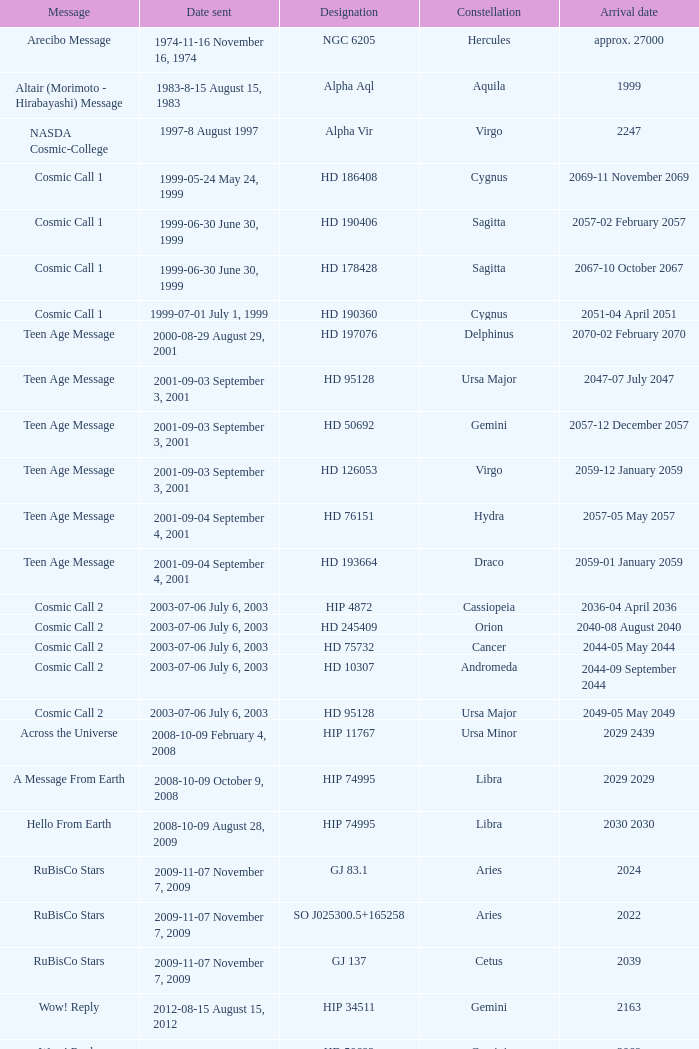Parse the table in full. {'header': ['Message', 'Date sent', 'Designation', 'Constellation', 'Arrival date'], 'rows': [['Arecibo Message', '1974-11-16 November 16, 1974', 'NGC 6205', 'Hercules', 'approx. 27000'], ['Altair (Morimoto - Hirabayashi) Message', '1983-8-15 August 15, 1983', 'Alpha Aql', 'Aquila', '1999'], ['NASDA Cosmic-College', '1997-8 August 1997', 'Alpha Vir', 'Virgo', '2247'], ['Cosmic Call 1', '1999-05-24 May 24, 1999', 'HD 186408', 'Cygnus', '2069-11 November 2069'], ['Cosmic Call 1', '1999-06-30 June 30, 1999', 'HD 190406', 'Sagitta', '2057-02 February 2057'], ['Cosmic Call 1', '1999-06-30 June 30, 1999', 'HD 178428', 'Sagitta', '2067-10 October 2067'], ['Cosmic Call 1', '1999-07-01 July 1, 1999', 'HD 190360', 'Cygnus', '2051-04 April 2051'], ['Teen Age Message', '2000-08-29 August 29, 2001', 'HD 197076', 'Delphinus', '2070-02 February 2070'], ['Teen Age Message', '2001-09-03 September 3, 2001', 'HD 95128', 'Ursa Major', '2047-07 July 2047'], ['Teen Age Message', '2001-09-03 September 3, 2001', 'HD 50692', 'Gemini', '2057-12 December 2057'], ['Teen Age Message', '2001-09-03 September 3, 2001', 'HD 126053', 'Virgo', '2059-12 January 2059'], ['Teen Age Message', '2001-09-04 September 4, 2001', 'HD 76151', 'Hydra', '2057-05 May 2057'], ['Teen Age Message', '2001-09-04 September 4, 2001', 'HD 193664', 'Draco', '2059-01 January 2059'], ['Cosmic Call 2', '2003-07-06 July 6, 2003', 'HIP 4872', 'Cassiopeia', '2036-04 April 2036'], ['Cosmic Call 2', '2003-07-06 July 6, 2003', 'HD 245409', 'Orion', '2040-08 August 2040'], ['Cosmic Call 2', '2003-07-06 July 6, 2003', 'HD 75732', 'Cancer', '2044-05 May 2044'], ['Cosmic Call 2', '2003-07-06 July 6, 2003', 'HD 10307', 'Andromeda', '2044-09 September 2044'], ['Cosmic Call 2', '2003-07-06 July 6, 2003', 'HD 95128', 'Ursa Major', '2049-05 May 2049'], ['Across the Universe', '2008-10-09 February 4, 2008', 'HIP 11767', 'Ursa Minor', '2029 2439'], ['A Message From Earth', '2008-10-09 October 9, 2008', 'HIP 74995', 'Libra', '2029 2029'], ['Hello From Earth', '2008-10-09 August 28, 2009', 'HIP 74995', 'Libra', '2030 2030'], ['RuBisCo Stars', '2009-11-07 November 7, 2009', 'GJ 83.1', 'Aries', '2024'], ['RuBisCo Stars', '2009-11-07 November 7, 2009', 'SO J025300.5+165258', 'Aries', '2022'], ['RuBisCo Stars', '2009-11-07 November 7, 2009', 'GJ 137', 'Cetus', '2039'], ['Wow! Reply', '2012-08-15 August 15, 2012', 'HIP 34511', 'Gemini', '2163'], ['Wow! Reply', '2012-08-15 August 15, 2012', 'HD 50692', 'Gemini', '2069'], ['Wow! Reply', '2012-08-15 August 15, 2012', 'HD 75732', 'Cancer', '2053'], ['Lone Signal', '2013-07-10 July 10, 2013', 'HD 119850', 'Boötes', '2031']]} Where is Hip 4872? Cassiopeia. 